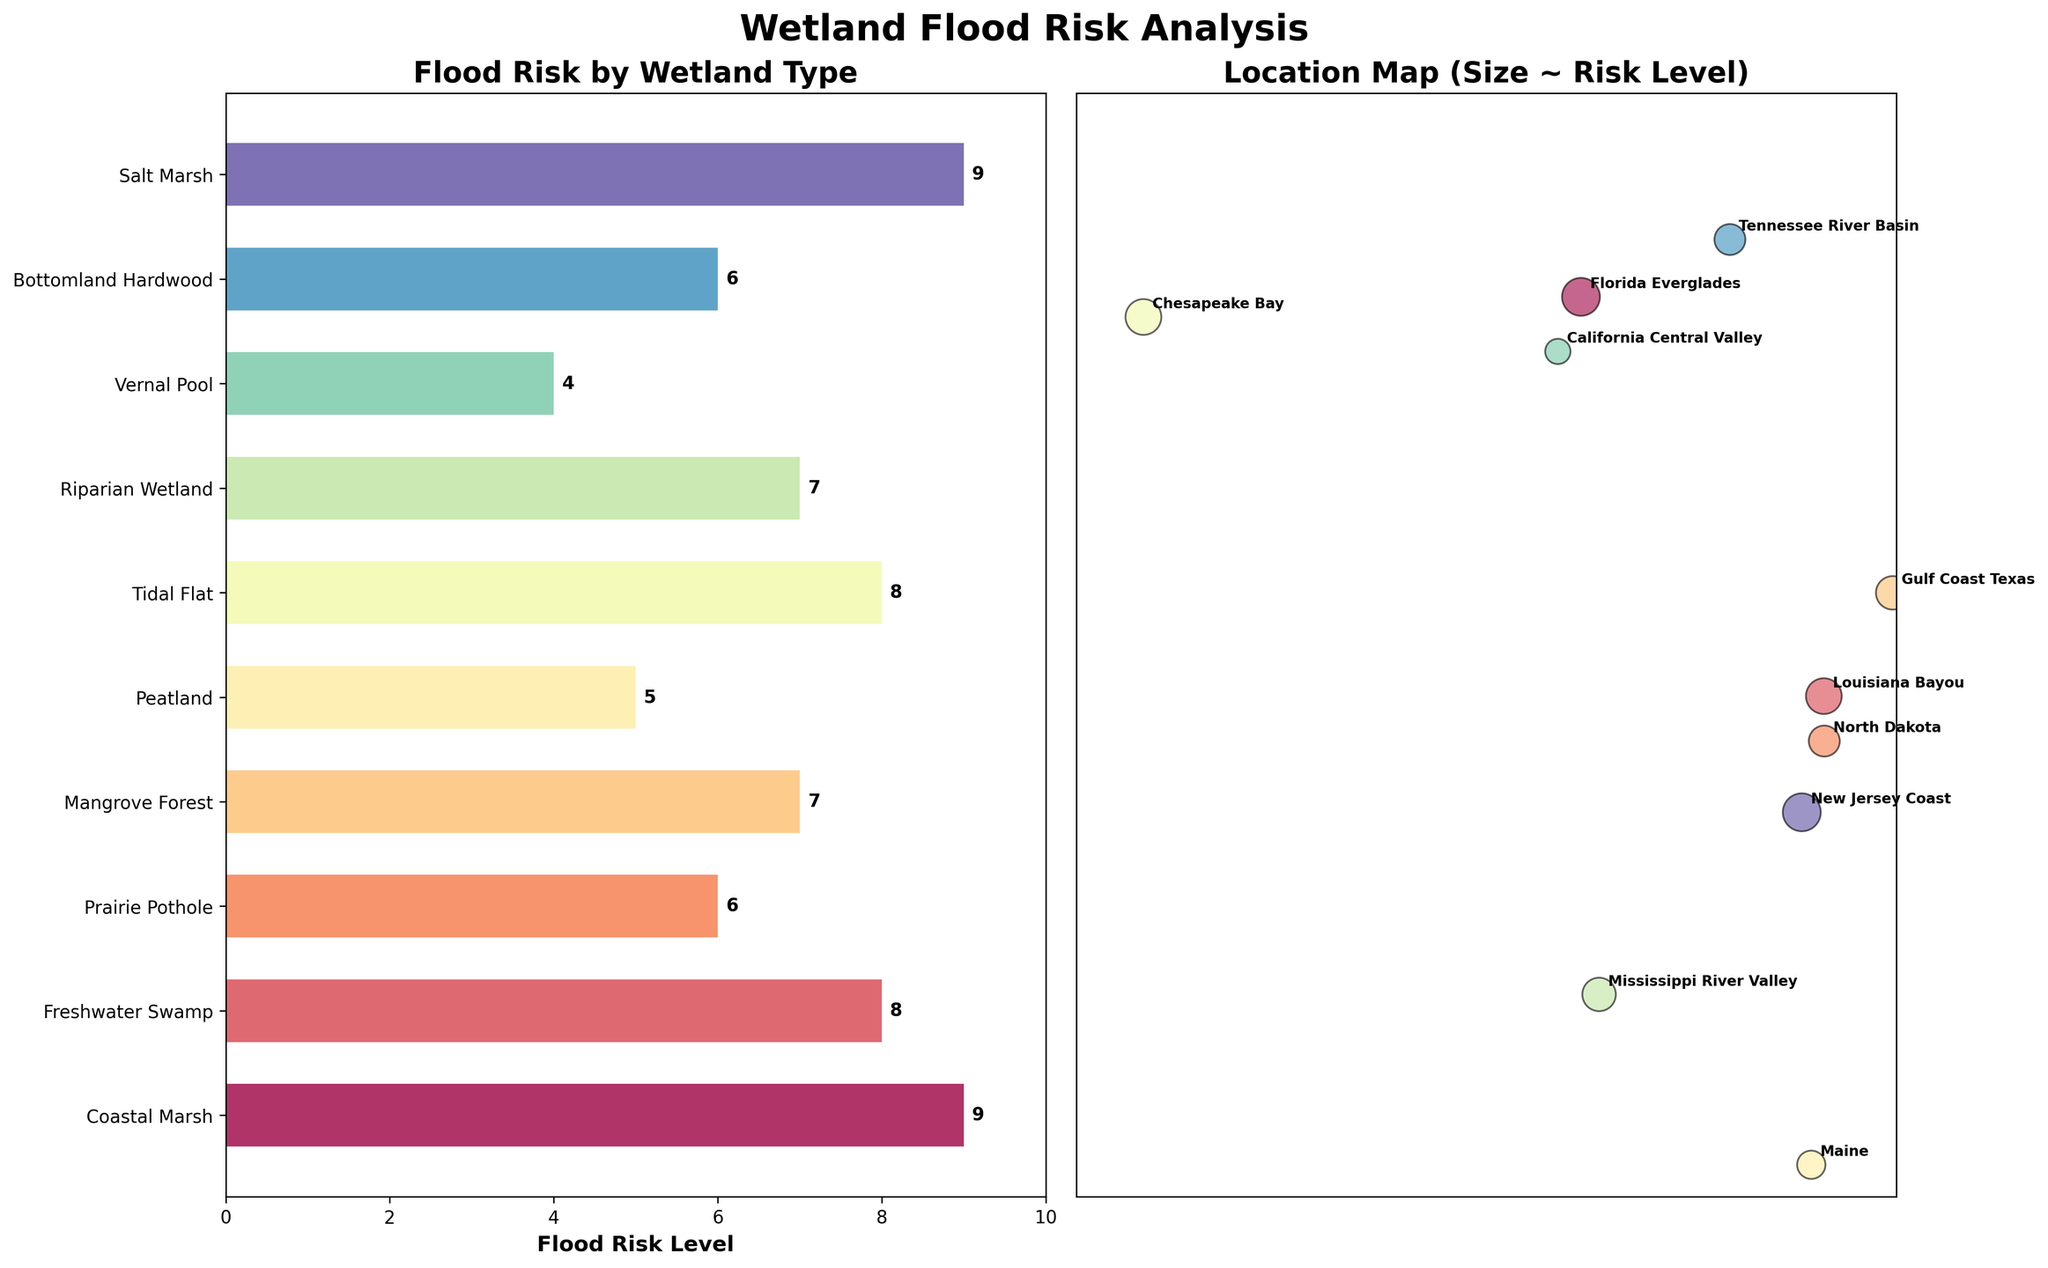How many different wetland types are visualized in the bar plot? There are 10 bars in the plot, each representing a different wetland type.
Answer: 10 Which wetland type has the highest flood risk level? The bar plot shows that both Coastal Marsh and Salt Marsh have the highest flood risk levels with a value of 9.
Answer: Coastal Marsh and Salt Marsh What is the title of the bar plot? The title is located at the top of the first subplot and reads "Flood Risk by Wetland Type".
Answer: Flood Risk by Wetland Type Compare the flood risk levels of the Freshwater Swamp and the Riparian Wetland. Which has a higher flood risk level? By comparing the heights of the bars, Freshwater Swamp has a flood risk level of 8, while Riparian Wetland has a flood risk level of 7.
Answer: Freshwater Swamp What is the average flood risk level across all wetland types? To calculate the average, sum all the flood risk levels and divide by the number of wetland types: (9+8+6+7+5+8+7+4+6+9) / 10 = 69 / 10 = 6.9.
Answer: 6.9 Which location is associated with the Vernal Pool wetland type and what is its flood risk level? The bar plot shows that Vernal Pool corresponds to California Central Valley, with a flood risk level of 4.
Answer: California Central Valley, 4 What is the range of flood risk levels shown in the bar plot? The flood risk levels range from the lowest value of 4 (Vernal Pool) to the highest value of 9 (Coastal Marsh and Salt Marsh).
Answer: 4 to 9 Identify the location on the scatter plot with the largest bubble size. Which wetland type does it represent? The bubble size on the scatter plot correlates with the flood risk level. The largest bubbles represent the Coastal Marsh and Salt Marsh, located in the Florida Everglades and New Jersey Coast.
Answer: Coastal Marsh (Florida Everglades) and Salt Marsh (New Jersey Coast) What relationship is depicted by the bubbles in the scatter plot? The size of the bubbles in the scatter plot represents the flood risk levels. Larger bubbles indicate higher flood risk levels.
Answer: Bubble size ~ Flood Risk Level Which wetland type has the same flood risk level as Bottomland Hardwood? From the bar plot, Bottomland Hardwood has a flood risk level of 6. Prairie Pothole also has a flood risk level of 6.
Answer: Prairie Pothole 